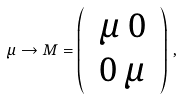Convert formula to latex. <formula><loc_0><loc_0><loc_500><loc_500>\mu \rightarrow M = \left ( \begin{array} { c c } { \, \mu \, 0 \, } \\ { \, 0 \, \mu \, } \end{array} \right ) \, ,</formula> 